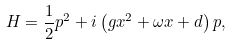<formula> <loc_0><loc_0><loc_500><loc_500>H = \frac { 1 } { 2 } p ^ { 2 } + i \left ( g x ^ { 2 } + \omega x + d \right ) p ,</formula> 